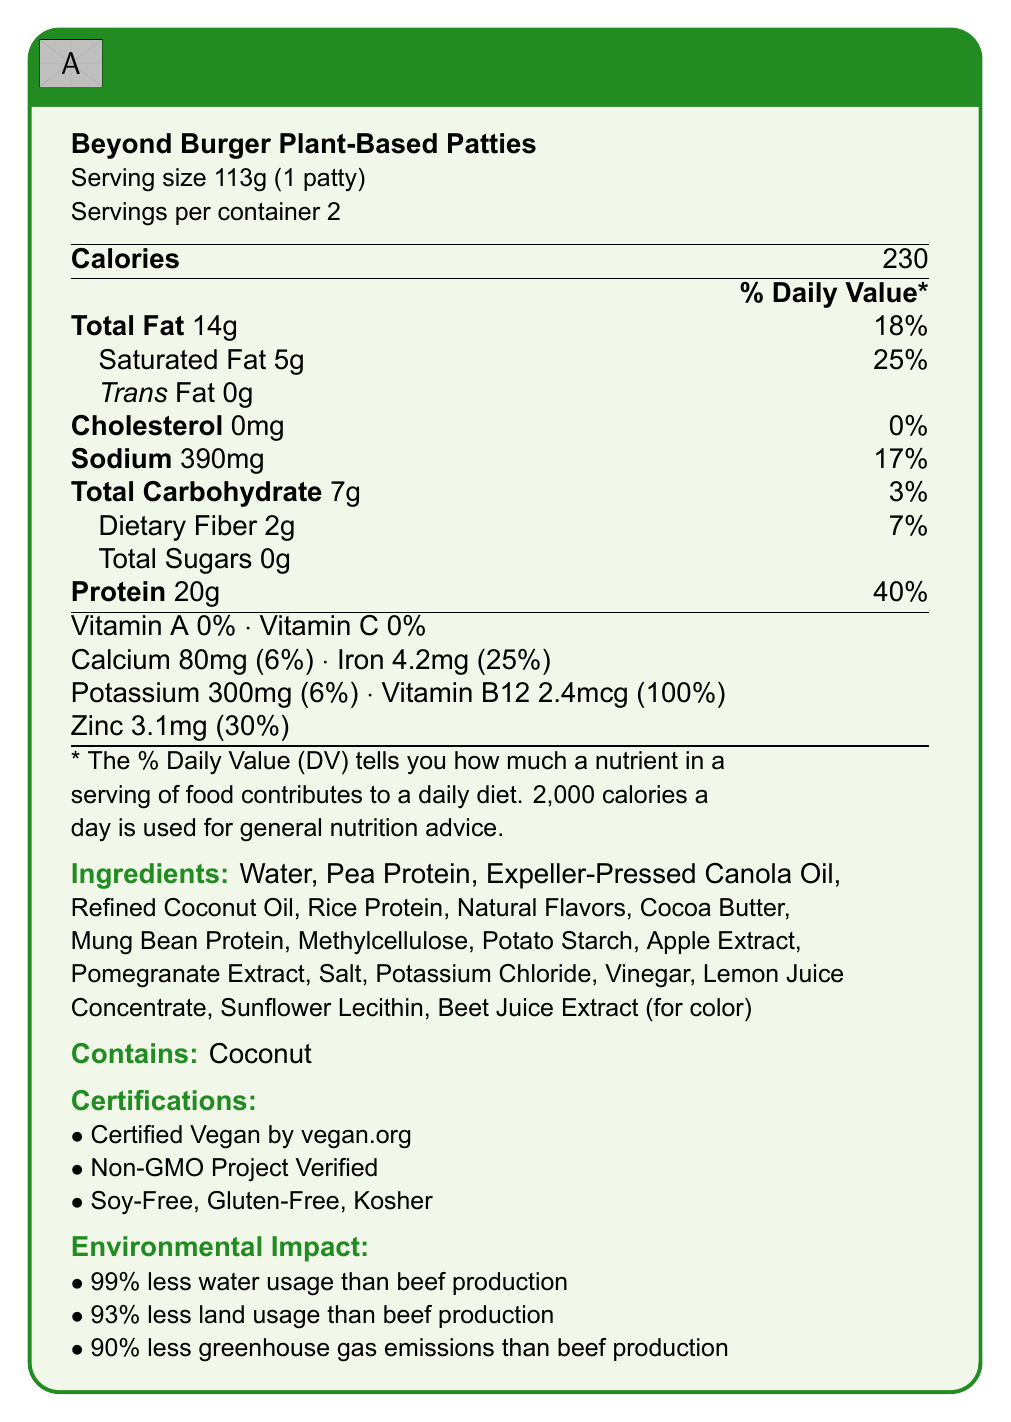what is the serving size of the Beyond Burger Plant-Based Patties? The serving size is explicitly mentioned as 113g which equals 1 patty.
Answer: 113g (1 patty) how many calories are in one serving of the Beyond Burger Plant-Based Patties? The document lists the calories per serving as 230.
Answer: 230 how much protein is in one serving of the Beyond Burger Plant-Based Patties? The document states there are 20g of protein per serving.
Answer: 20g what is the percentage of daily value for protein per serving? The daily value percentage for protein is listed as 40%.
Answer: 40% what are the main protein sources in the Beyond Burger Plant-Based Patties? The primary protein sources mentioned are Pea Protein, Rice Protein, and Mung Bean Protein.
Answer: Pea Protein, Rice Protein, Mung Bean Protein how much total fat is in one serving of the Beyond Burger Plant-Based Patties? The total fat content per serving is specified as 14g.
Answer: 14g which nutrient has a daily value percentage of 100% per serving? A. Vitamin B12 B. Iron C. Zinc D. Sodium Vitamin B12 has a daily value of 100% per serving.
Answer: A. Vitamin B12 which of the following ingredients is not in the Beyond Burger Plant-Based Patties? A. Soy Protein B. Pea Protein C. Rice Protein D. Mung Bean Protein Soy Protein is not listed among the ingredients.
Answer: A. Soy Protein are the Beyond Burger Plant-Based Patties certified vegan? The document states that the patties are certified vegan by vegan.org.
Answer: Yes do the Beyond Burger Plant-Based Patties contain any cholesterol? The document indicates a cholesterol content of 0mg.
Answer: No what is the environmental impact of the Beyond Burger Plant-Based Patties compared to beef production? The document highlights that it uses 99% less water, 93% less land, and emits 90% less greenhouse gases compared to beef production.
Answer: It uses 99% less water, 93% less land, and emits 90% less greenhouse gases. what is the percentage of daily value for iron per serving? The daily value percentage for iron per serving is listed as 25%.
Answer: 25% does the Beyond Burger Plant-Based Patties use gluten in its ingredients? The document states it is gluten-free.
Answer: No what is the PDCAAS score for the protein quality of the patties? The protein quality PDCAAS score is mentioned as 0.92.
Answer: 0.92 which ingredient is used for coloring in the Beyond Burger Plant-Based Patties? A. Carrot Extract B. Beet Juice Extract C. Turmeric Powder D. Spinach Extract Beet Juice Extract is listed as the coloring ingredient.
Answer: B. Beet Juice Extract describe the nutritional profile of the Beyond Burger Plant-Based Patties. The detailed nutritional profile includes essential details like calories, fats, cholesterol, sodium, carbohydrates, fiber, protein, and other vitamins and minerals.
Answer: The Beyond Burger Plant-Based Patties have 230 calories per serving, with 14g of total fat, 5g of saturated fat, no trans fat, 0mg cholesterol, 390mg sodium, 7g total carbohydrates including 2g dietary fiber, and 20g protein. Vitamin B12 is present at 100% of the daily value. They also contain calcium, iron, potassium, and zinc. how long can the Beyond Burger Plant-Based Patties be stored refrigerated? The document specifies a shelf life of 10 days when refrigerated.
Answer: 10 days what is the maximum internal temperature required to cook the Beyond Burger Plant-Based Patties? The cooking instructions state to cook thoroughly to an internal temperature of 165°F.
Answer: 165°F are the Beyond Burger Plant-Based Patties comparable to any specific type of ground beef in terms of protein content? The document mentions that the protein content is comparable to 80/20 ground beef.
Answer: Yes, similar to 80/20 ground beef. what is the recommended serving size for kids aged 3-4 years old? The document does not provide specific serving size recommendations for kids aged 3-4 years old.
Answer: Cannot be determined 